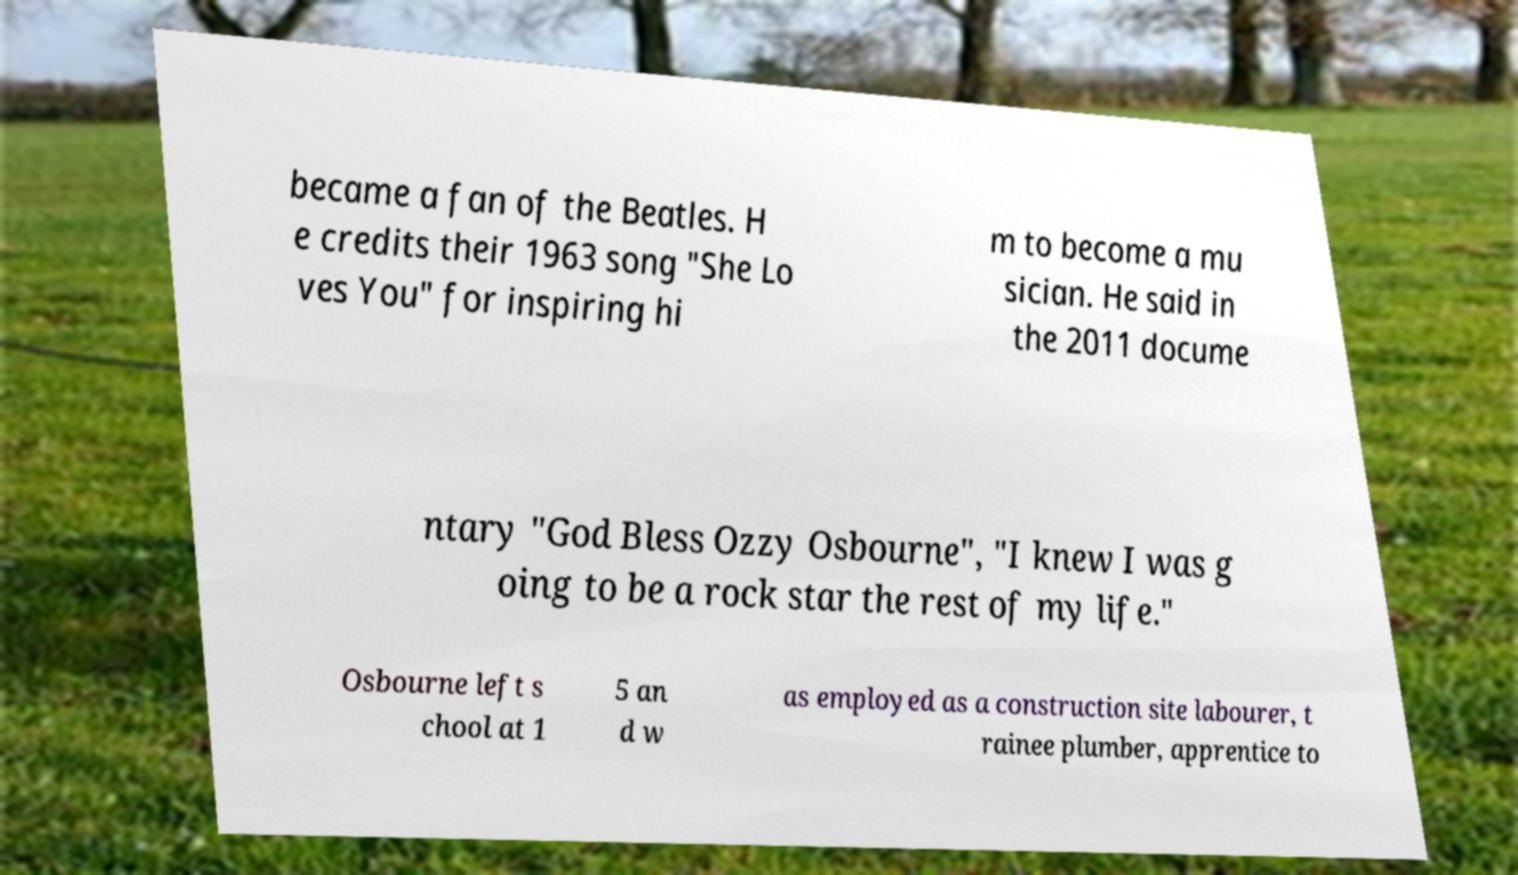There's text embedded in this image that I need extracted. Can you transcribe it verbatim? became a fan of the Beatles. H e credits their 1963 song "She Lo ves You" for inspiring hi m to become a mu sician. He said in the 2011 docume ntary "God Bless Ozzy Osbourne", "I knew I was g oing to be a rock star the rest of my life." Osbourne left s chool at 1 5 an d w as employed as a construction site labourer, t rainee plumber, apprentice to 